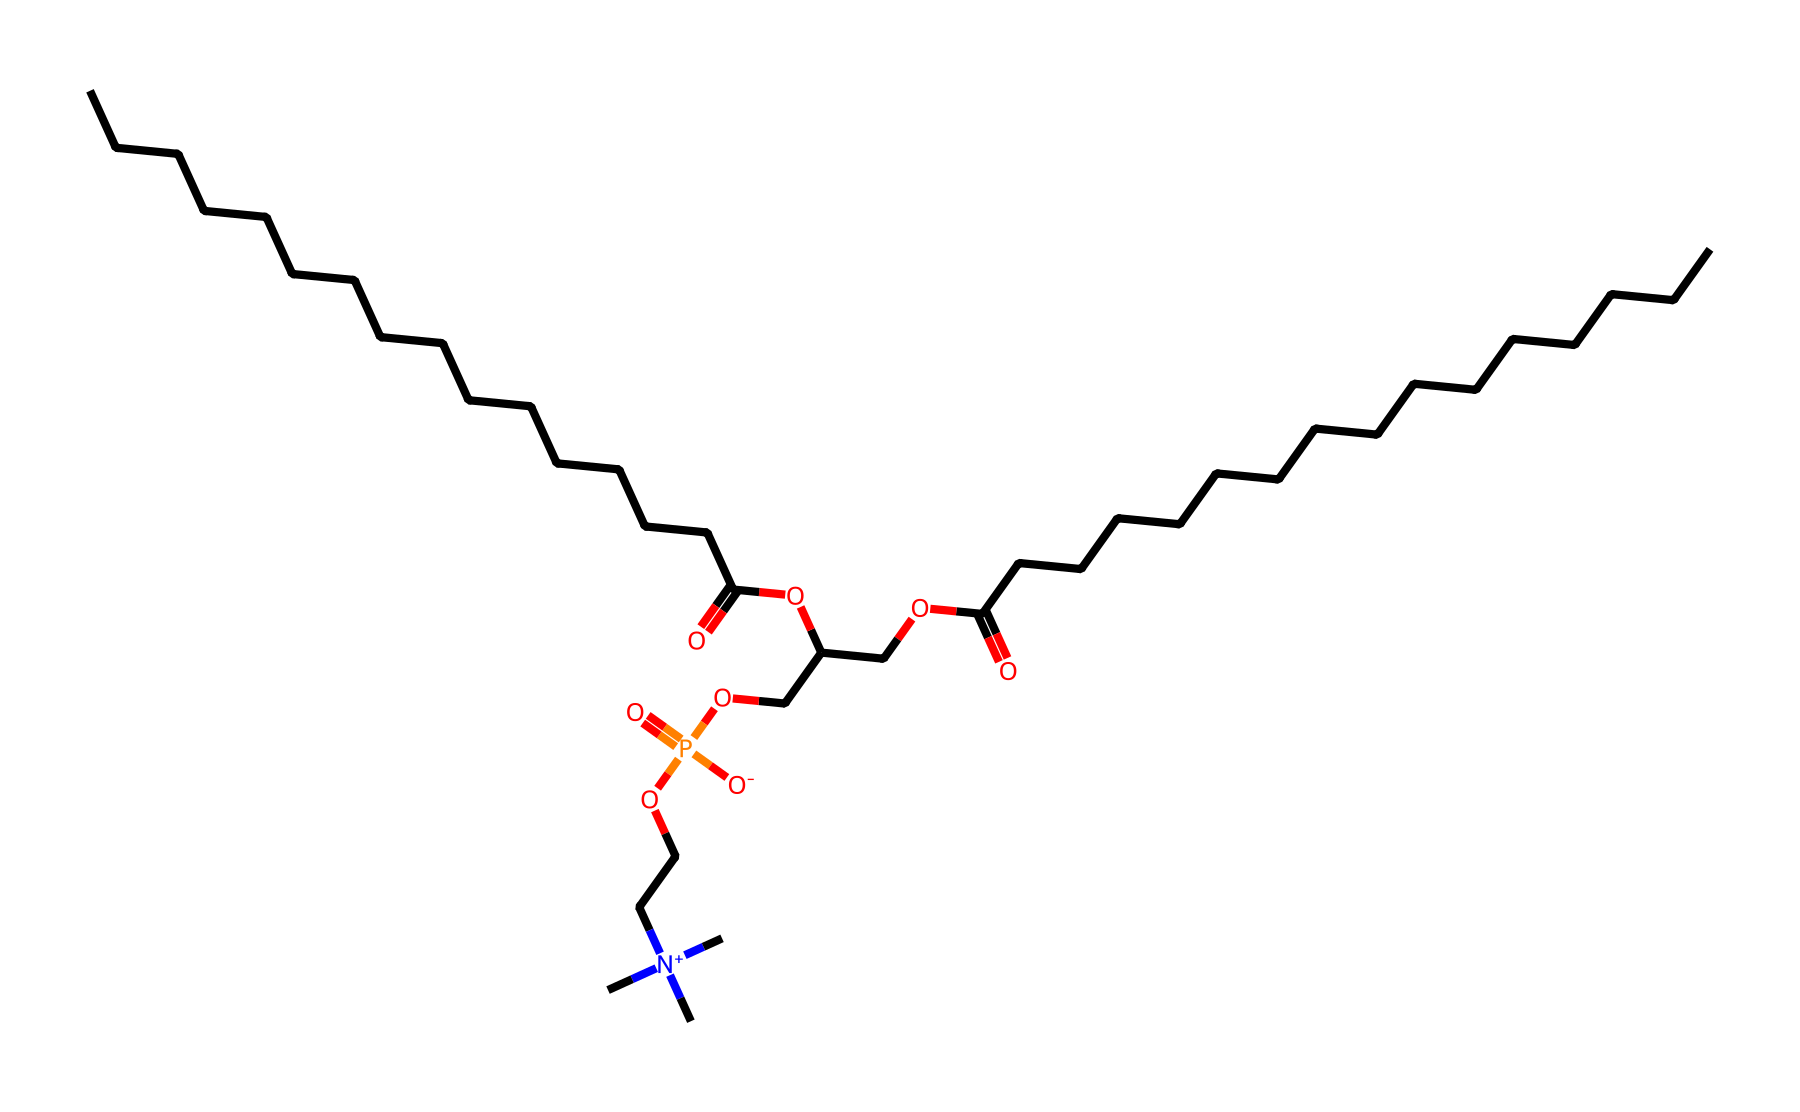What is the main functional group present in lecithin? The SMILES representation shows that the chemical contains a phosphate group (P=O and O), which is characteristic of lecithin, a phospholipid.
Answer: phosphate group How many carbon atoms are present in the lecithin structure? Analyzing the SMILES, there are several continuous carbon chains. There are 26 carbon atoms represented in total (counting from the carbon chains).
Answer: 26 What type of lipid is lecithin classified as? Lecithin contains a phosphate group and fatty acid chains, classifying it as a phospholipid, which is a common type of lipid.
Answer: phospholipid What part of the lecithin structure contributes to its emulsifying properties? The structure includes hydrophilic (water-attracting) phosphate group combined with hydrophobic (water-repelling) fatty acid chains. This dual nature allows it to act as an emulsifier.
Answer: hydrophilic and hydrophobic regions Does lecithin contain a quaternary ammonium compound? Yes, the structure shows a nitrogen atom with three methyl groups attached ([N+](C)(C)C), indicating the presence of a quaternary ammonium component, which adds functionality to lecithin.
Answer: yes What is the overall charge of the nitrogen in the lecithin structure? The nitrogen (N) in the structure is positively charged as indicated by the "[N+]" notation, which signifies a quaternary ammonium ion.
Answer: positive charge 